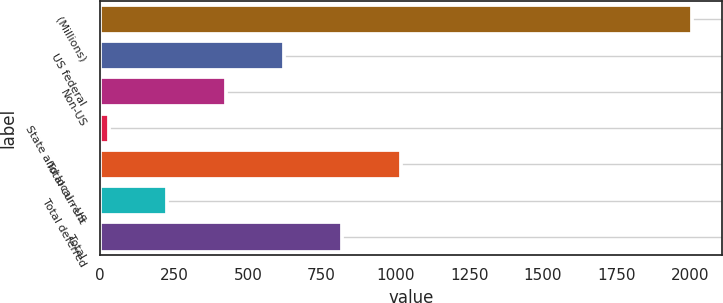Convert chart to OTSL. <chart><loc_0><loc_0><loc_500><loc_500><bar_chart><fcel>(Millions)<fcel>US federal<fcel>Non-US<fcel>State and local - US<fcel>Total current<fcel>Total deferred<fcel>Total<nl><fcel>2006<fcel>622.1<fcel>424.4<fcel>29<fcel>1017.5<fcel>226.7<fcel>819.8<nl></chart> 